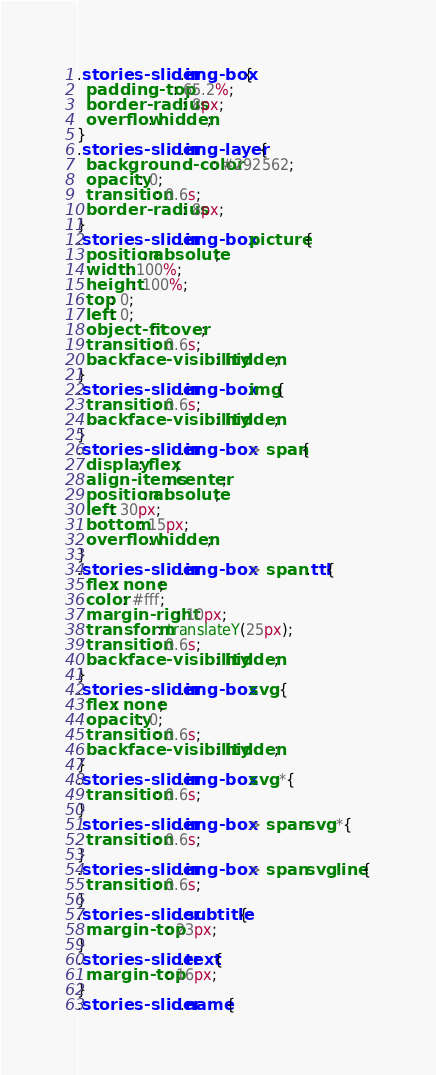<code> <loc_0><loc_0><loc_500><loc_500><_CSS_>.stories-slider .img-box{
  padding-top: 65.2%;
  border-radius: 8px;
  overflow: hidden;
}
.stories-slider .img-layer {
  background-color: #292562;
  opacity: 0;
  transition: 0.6s;
  border-radius: 8px;
}
.stories-slider .img-box picture {
  position: absolute;
  width: 100%;
  height: 100%;
  top: 0;
  left: 0;
  object-fit: cover;
  transition: 0.6s;
  backface-visibility: hidden;
}
.stories-slider .img-box img{
  transition: 0.6s;
  backface-visibility: hidden;
}
.stories-slider .img-box > span{
  display: flex;
  align-items: center;
  position: absolute;
  left: 30px;
  bottom: 15px;
  overflow: hidden;
}
.stories-slider .img-box > span .ttl{
  flex: none;
  color: #fff;
  margin-right: 10px;
  transform: translateY(25px);
  transition: 0.6s;
  backface-visibility: hidden;
}
.stories-slider .img-box svg {
  flex: none;
  opacity: 0;
  transition: 0.6s;
  backface-visibility: hidden;
}
.stories-slider .img-box svg *{
  transition: 0.6s;
}
.stories-slider .img-box > span svg *{
  transition: 0.6s;
}
.stories-slider .img-box > span svg line{
  transition: 0.6s;
}
.stories-slider .subtitle{
  margin-top: 23px;
}
.stories-slider .text{
  margin-top: 16px;
}
.stories-slider .name{</code> 